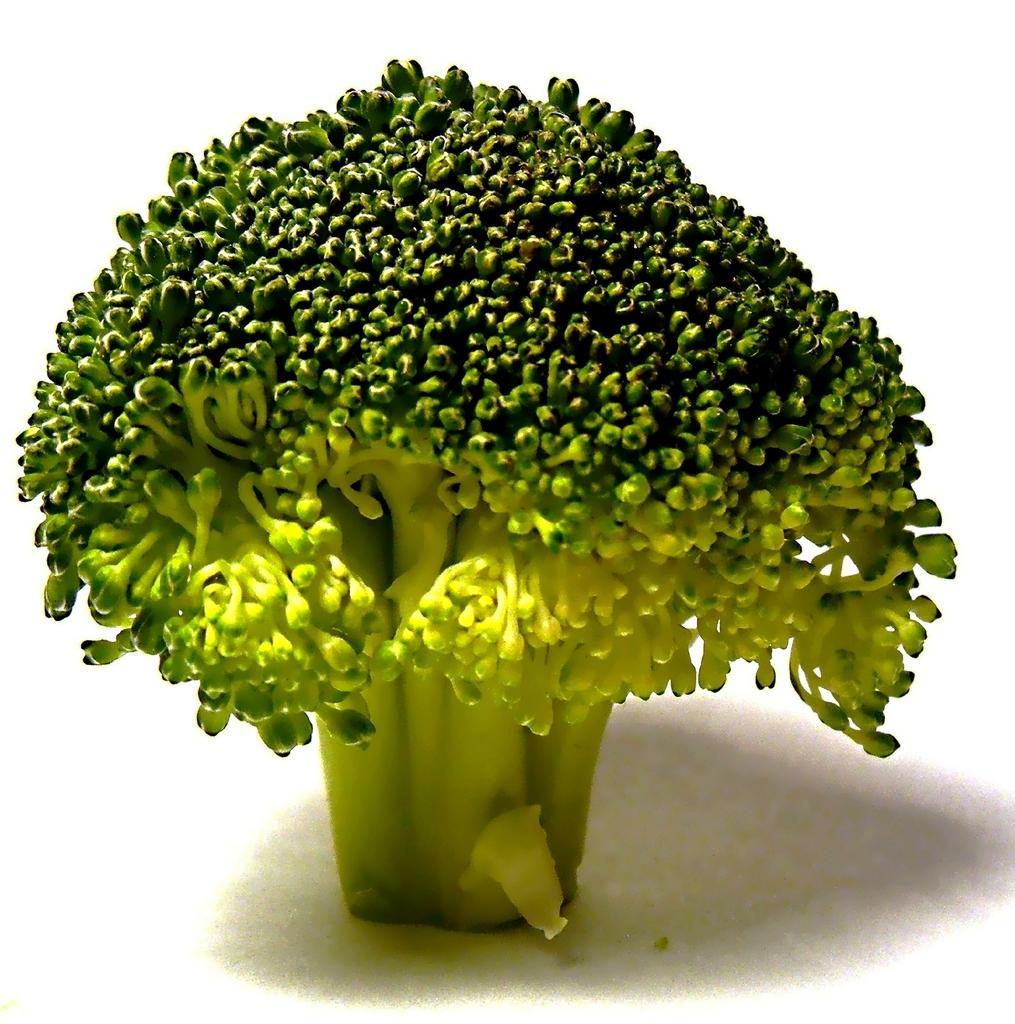Can you describe this image briefly? In this image its look like a green vegetable, and background is white. 